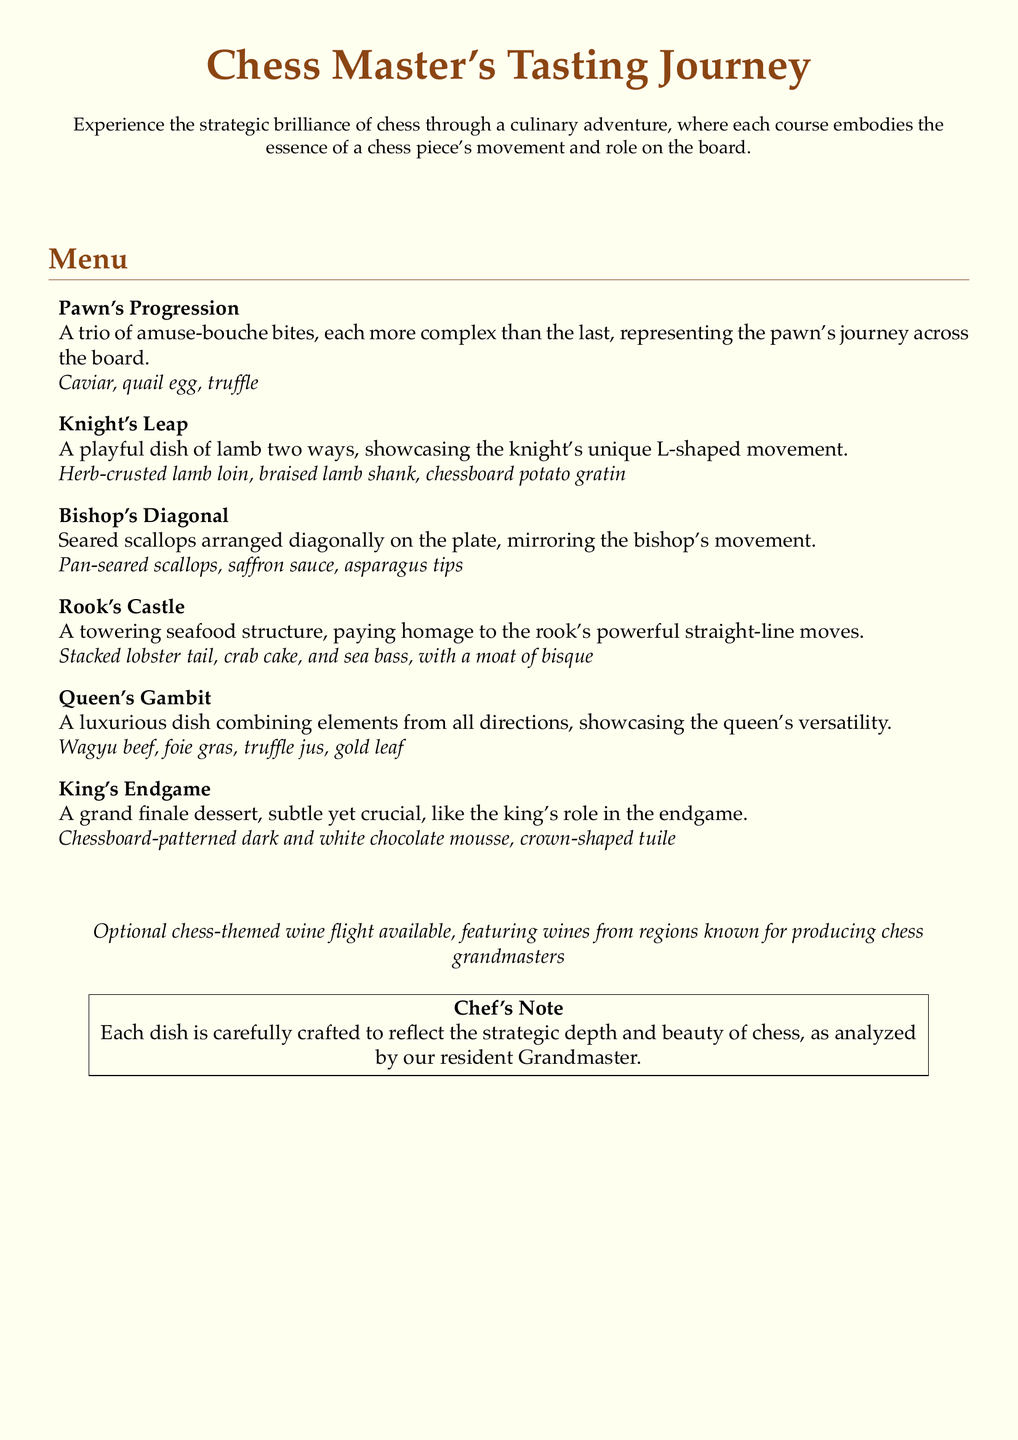What is the first course of the menu? The first course is named "Pawn's Progression," which is the first item listed in the menu.
Answer: Pawn's Progression What type of meat is featured in the "Knight's Leap" dish? The "Knight's Leap" dish features lamb prepared in two ways, which is specified in the description.
Answer: Lamb How many amuse-bouche bites are in the "Pawn's Progression"? The description of "Pawn's Progression" states that it includes a trio of bites.
Answer: Trio What seafood is used in the "Rook's Castle"? The "Rook's Castle" includes lobster tail, crab cake, and sea bass as its components.
Answer: Lobster tail Which dish represents the queen? "Queen's Gambit" is the dish that represents the queen's versatility.
Answer: Queen's Gambit What is unique about the "Bishop's Diagonal" presentation? The presentation of the "Bishop's Diagonal" involves seared scallops arranged diagonally, mirroring the bishop's movement.
Answer: Arranged diagonally What dessert is served as the grand finale? The dessert described as a grand finale is the "King's Endgame."
Answer: King's Endgame Is there an optional wine pairing? The menu mentions an optional chess-themed wine flight that is available.
Answer: Yes What type of chocolate is used in the grand finale dessert? The "King's Endgame" dessert features dark and white chocolate mousse, as specified.
Answer: Dark and white chocolate 